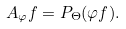Convert formula to latex. <formula><loc_0><loc_0><loc_500><loc_500>A _ { \varphi } f = P _ { \Theta } ( \varphi f ) .</formula> 